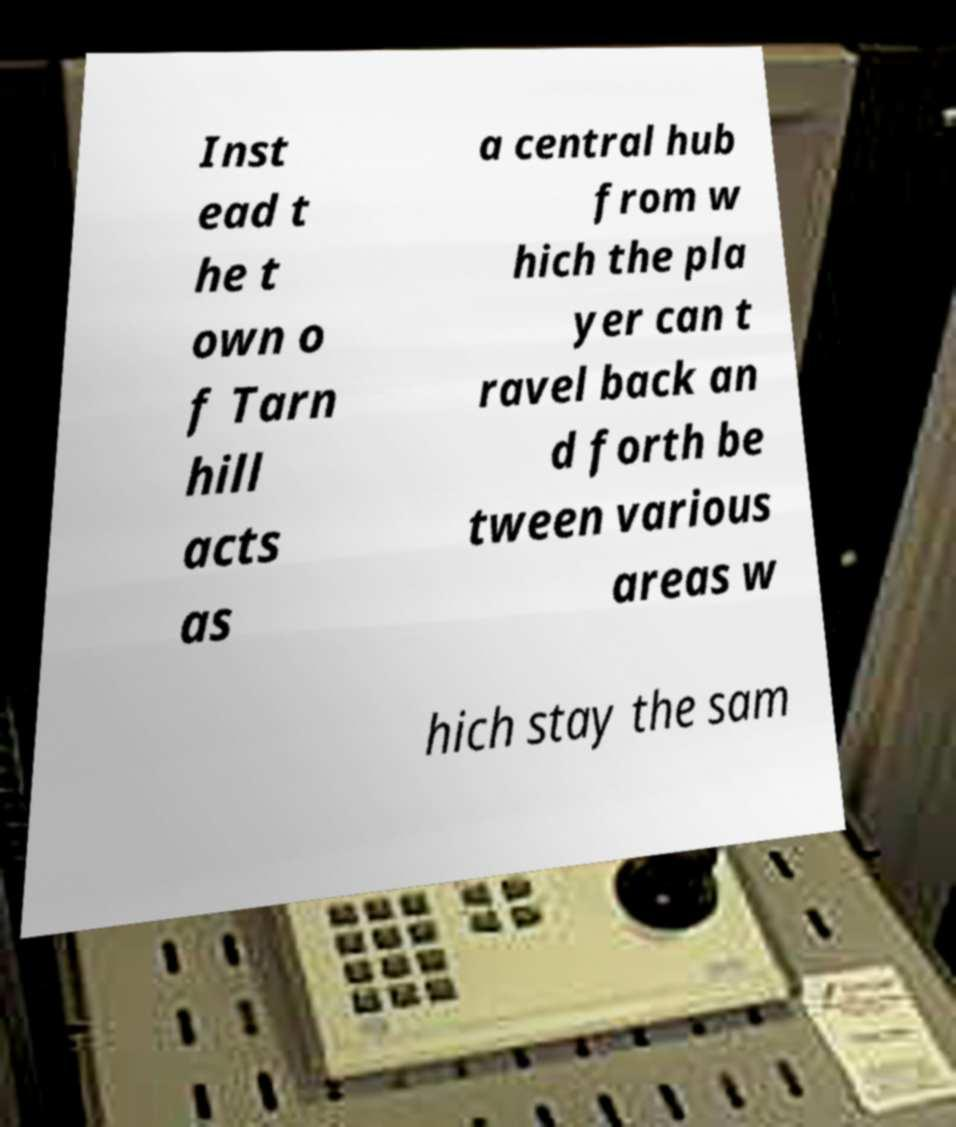Could you extract and type out the text from this image? Inst ead t he t own o f Tarn hill acts as a central hub from w hich the pla yer can t ravel back an d forth be tween various areas w hich stay the sam 